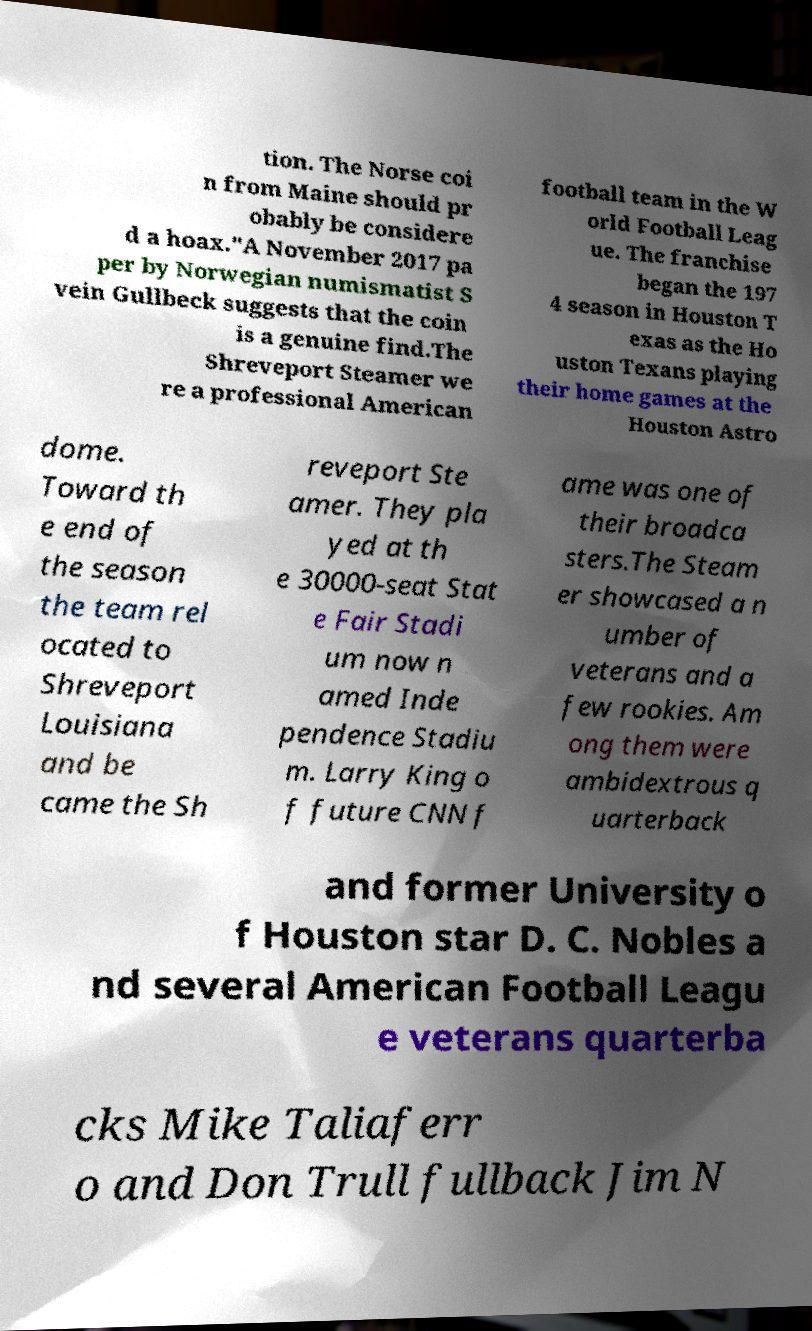I need the written content from this picture converted into text. Can you do that? tion. The Norse coi n from Maine should pr obably be considere d a hoax."A November 2017 pa per by Norwegian numismatist S vein Gullbeck suggests that the coin is a genuine find.The Shreveport Steamer we re a professional American football team in the W orld Football Leag ue. The franchise began the 197 4 season in Houston T exas as the Ho uston Texans playing their home games at the Houston Astro dome. Toward th e end of the season the team rel ocated to Shreveport Louisiana and be came the Sh reveport Ste amer. They pla yed at th e 30000-seat Stat e Fair Stadi um now n amed Inde pendence Stadiu m. Larry King o f future CNN f ame was one of their broadca sters.The Steam er showcased a n umber of veterans and a few rookies. Am ong them were ambidextrous q uarterback and former University o f Houston star D. C. Nobles a nd several American Football Leagu e veterans quarterba cks Mike Taliaferr o and Don Trull fullback Jim N 